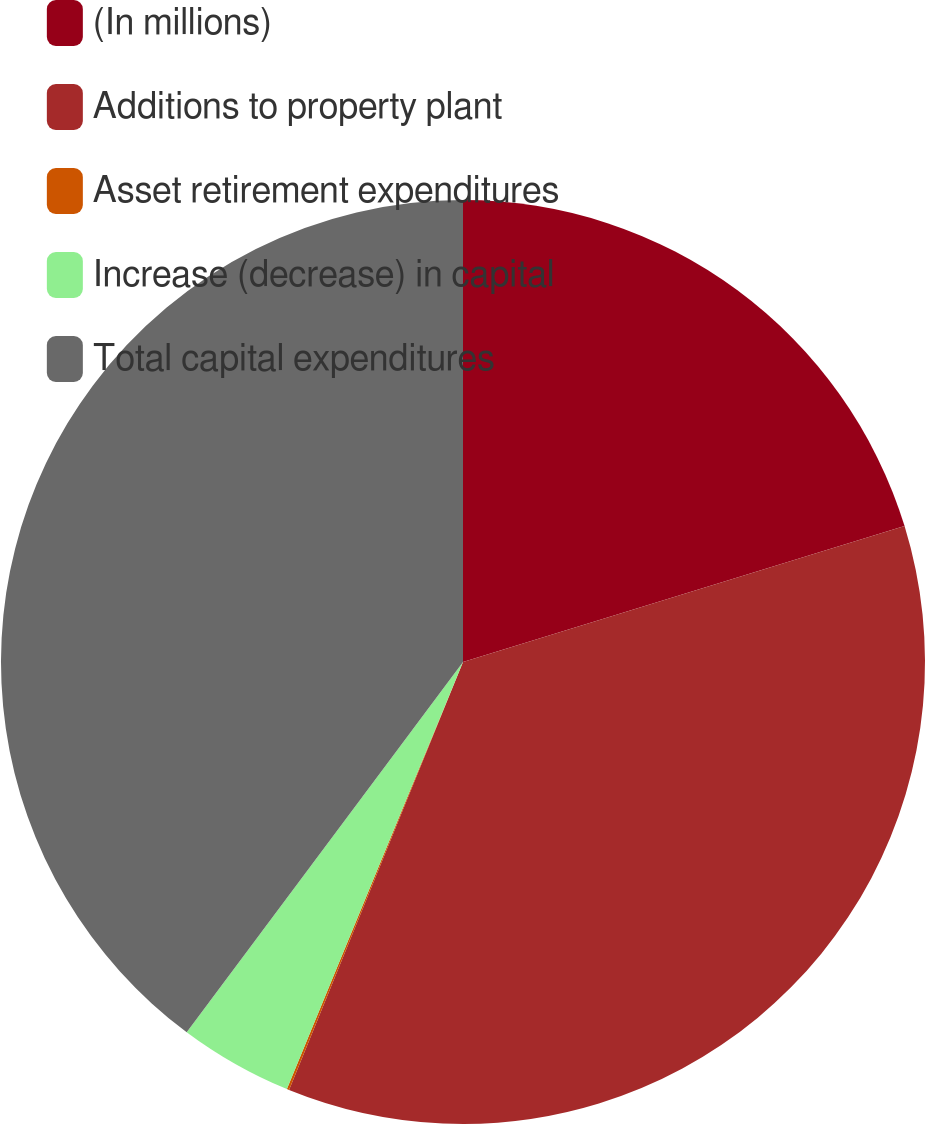<chart> <loc_0><loc_0><loc_500><loc_500><pie_chart><fcel>(In millions)<fcel>Additions to property plant<fcel>Asset retirement expenditures<fcel>Increase (decrease) in capital<fcel>Total capital expenditures<nl><fcel>20.25%<fcel>35.9%<fcel>0.08%<fcel>3.98%<fcel>39.8%<nl></chart> 